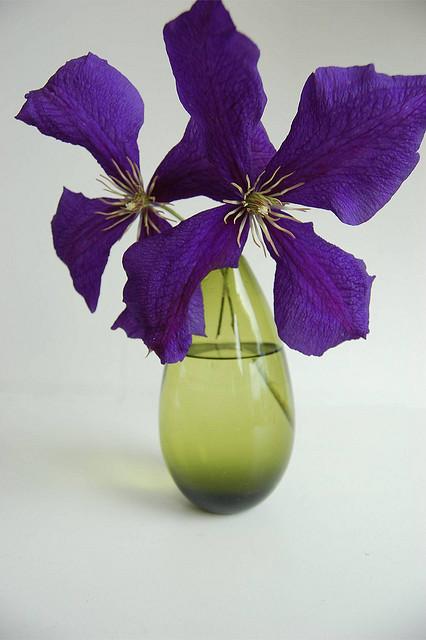What color are the flowers?
Give a very brief answer. Purple. What type of flower is this?
Short answer required. Lily. How much water is in this vase?
Quick response, please. Half. 